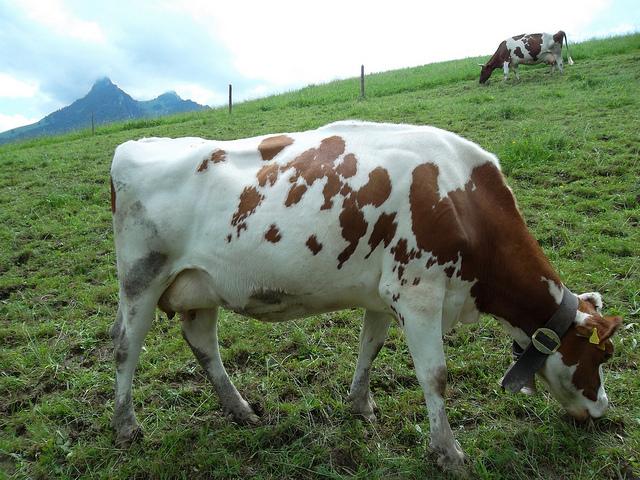Are any of the cows facing the camera?
Write a very short answer. No. What colors are the cows?
Be succinct. Brown and white. Do these animals all look alike?
Give a very brief answer. Yes. What is around the cows neck?
Keep it brief. Collar. Are these cows on a farm?
Answer briefly. Yes. 